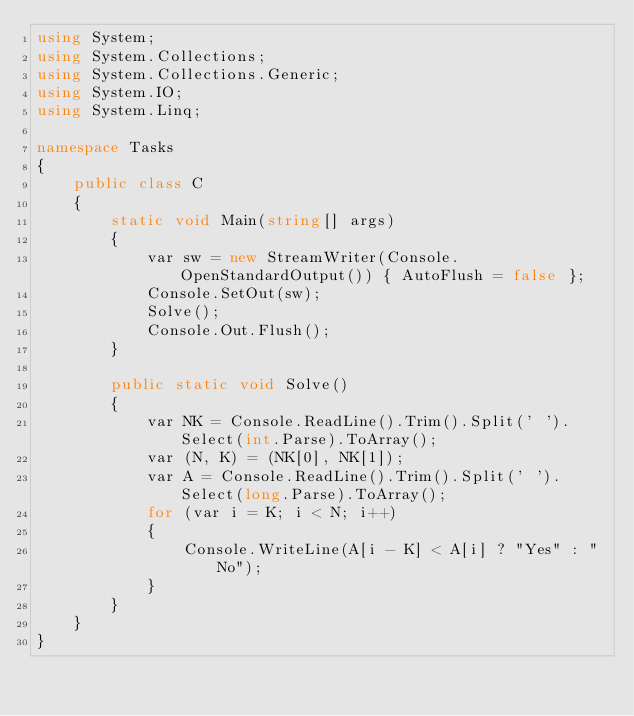<code> <loc_0><loc_0><loc_500><loc_500><_C#_>using System;
using System.Collections;
using System.Collections.Generic;
using System.IO;
using System.Linq;

namespace Tasks
{
    public class C
    {
        static void Main(string[] args)
        {
            var sw = new StreamWriter(Console.OpenStandardOutput()) { AutoFlush = false };
            Console.SetOut(sw);
            Solve();
            Console.Out.Flush();
        }

        public static void Solve()
        {
            var NK = Console.ReadLine().Trim().Split(' ').Select(int.Parse).ToArray();
            var (N, K) = (NK[0], NK[1]);
            var A = Console.ReadLine().Trim().Split(' ').Select(long.Parse).ToArray();
            for (var i = K; i < N; i++)
            {
                Console.WriteLine(A[i - K] < A[i] ? "Yes" : "No");
            }
        }
    }
}
</code> 